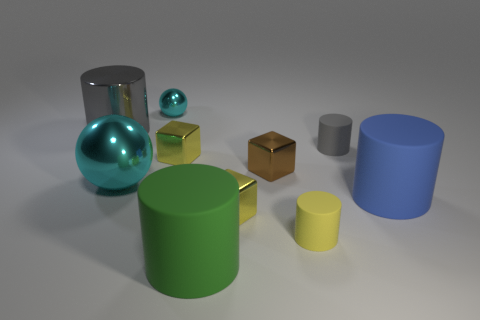Do the gray object that is right of the large green matte thing and the green thing have the same shape?
Give a very brief answer. Yes. What material is the small cylinder that is in front of the big cyan metallic ball?
Give a very brief answer. Rubber. What number of metal things are either cylinders or large balls?
Make the answer very short. 2. Are there any green matte objects that have the same size as the blue object?
Your answer should be compact. Yes. Is the number of tiny brown cubes that are behind the tiny brown object greater than the number of small cyan shiny objects?
Ensure brevity in your answer.  No. How many tiny objects are either gray matte cylinders or brown metallic cubes?
Ensure brevity in your answer.  2. What number of tiny brown things have the same shape as the gray matte object?
Keep it short and to the point. 0. The yellow cube on the left side of the matte object that is in front of the tiny yellow matte thing is made of what material?
Keep it short and to the point. Metal. What is the size of the rubber object that is right of the gray matte object?
Keep it short and to the point. Large. How many brown things are metal objects or tiny metallic things?
Offer a very short reply. 1. 